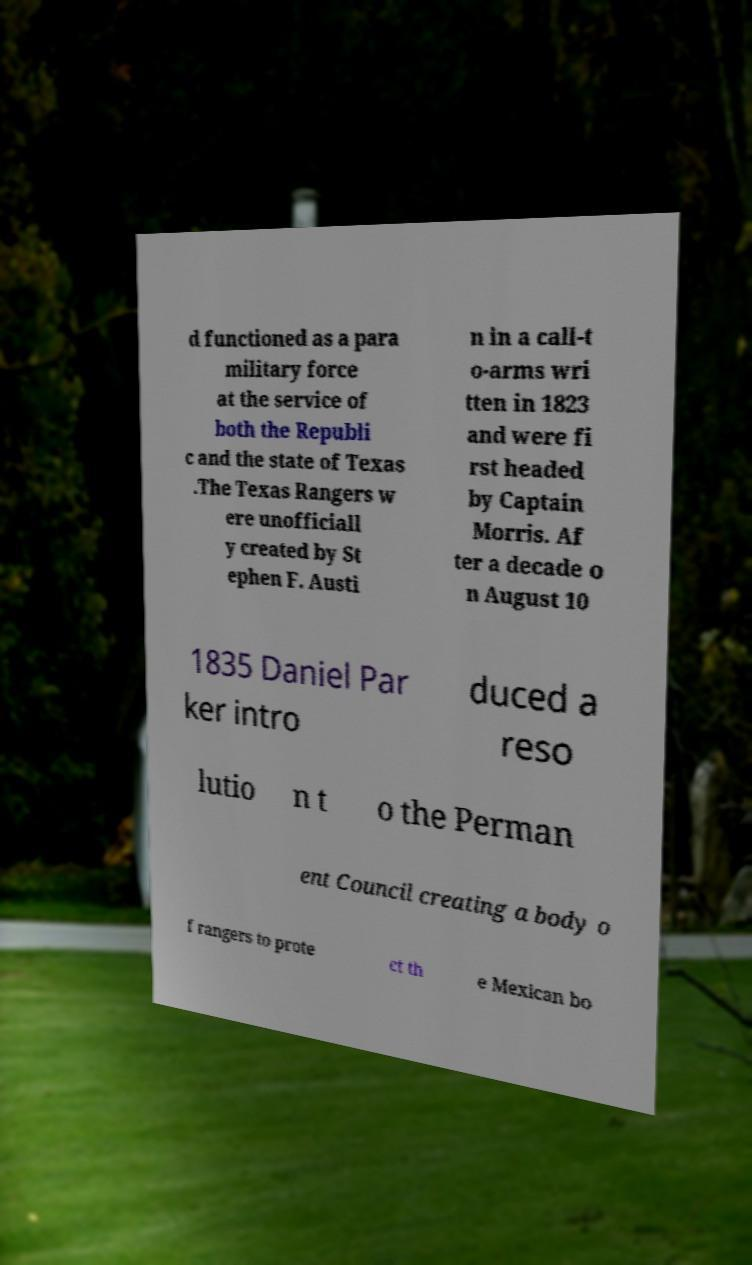Please read and relay the text visible in this image. What does it say? d functioned as a para military force at the service of both the Republi c and the state of Texas .The Texas Rangers w ere unofficiall y created by St ephen F. Austi n in a call-t o-arms wri tten in 1823 and were fi rst headed by Captain Morris. Af ter a decade o n August 10 1835 Daniel Par ker intro duced a reso lutio n t o the Perman ent Council creating a body o f rangers to prote ct th e Mexican bo 